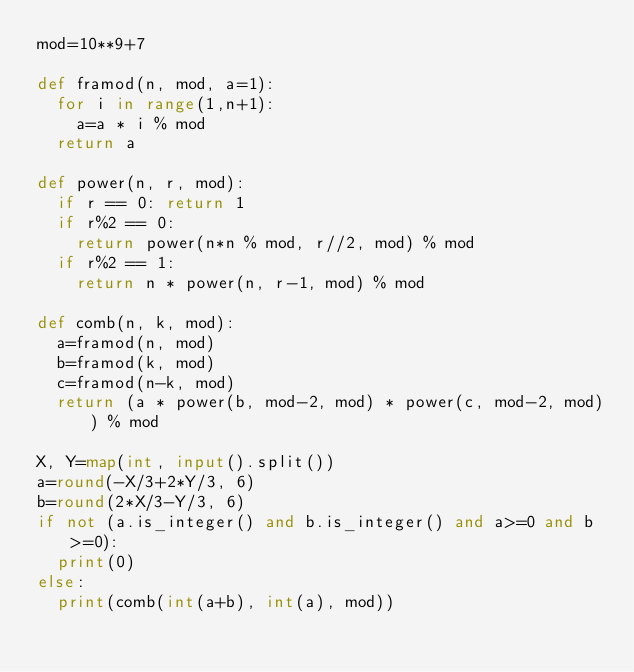<code> <loc_0><loc_0><loc_500><loc_500><_Python_>mod=10**9+7

def framod(n, mod, a=1):
  for i in range(1,n+1):
    a=a * i % mod
  return a
  
def power(n, r, mod):
  if r == 0: return 1
  if r%2 == 0:
    return power(n*n % mod, r//2, mod) % mod
  if r%2 == 1:
    return n * power(n, r-1, mod) % mod

def comb(n, k, mod):
  a=framod(n, mod)
  b=framod(k, mod)
  c=framod(n-k, mod)
  return (a * power(b, mod-2, mod) * power(c, mod-2, mod)) % mod
  
X, Y=map(int, input().split())
a=round(-X/3+2*Y/3, 6)
b=round(2*X/3-Y/3, 6)
if not (a.is_integer() and b.is_integer() and a>=0 and b>=0):
  print(0)
else:
  print(comb(int(a+b), int(a), mod))
</code> 